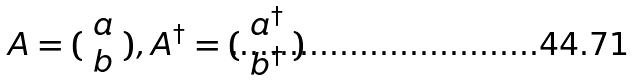<formula> <loc_0><loc_0><loc_500><loc_500>A = ( \begin{array} { c } a \\ b \end{array} ) , A ^ { \dagger } = ( \begin{array} { c } a ^ { \dagger } \\ b ^ { \dagger } \end{array} )</formula> 